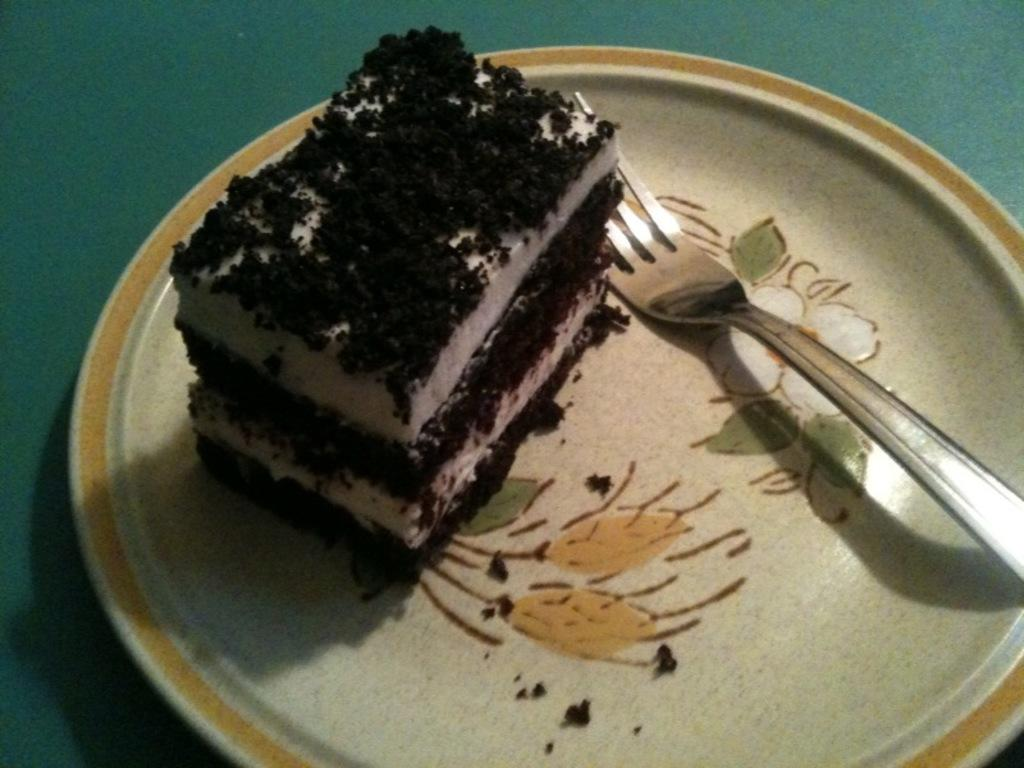What type of dessert is visible in the image? There is a piece of cake in the image. What utensil is present in the image? There is a fork in the image. On what surface is the plate with the cake and fork placed? The plate with the cake and fork is on a green surface. What type of muscle can be seen flexing in the image? There is no muscle visible in the image; it features a piece of cake, a fork, and a green surface. What type of cracker is present in the image? There is no cracker present in the image. 